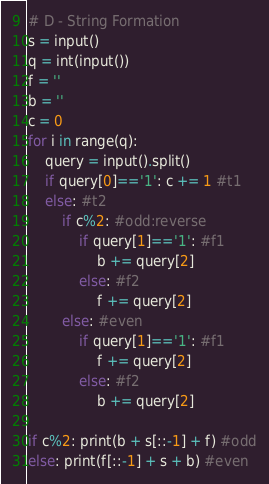Convert code to text. <code><loc_0><loc_0><loc_500><loc_500><_Python_># D - String Formation
s = input()
q = int(input())
f = ''
b = ''
c = 0
for i in range(q):
    query = input().split()
    if query[0]=='1': c += 1 #t1
    else: #t2
        if c%2: #odd:reverse
            if query[1]=='1': #f1
                b += query[2]
            else: #f2
                f += query[2]
        else: #even
            if query[1]=='1': #f1
                f += query[2]
            else: #f2
                b += query[2]

if c%2: print(b + s[::-1] + f) #odd
else: print(f[::-1] + s + b) #even</code> 